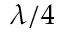<formula> <loc_0><loc_0><loc_500><loc_500>\lambda / 4</formula> 